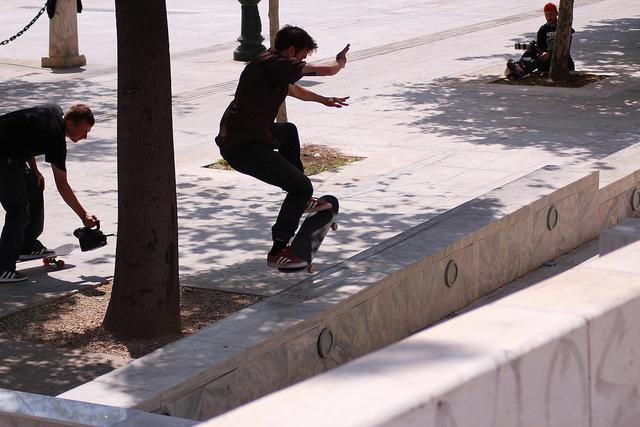What past time is the rightmost person involved in?

Choices:
A) wakeboarding
B) skate boarding
C) photography
D) beer drinking photography 